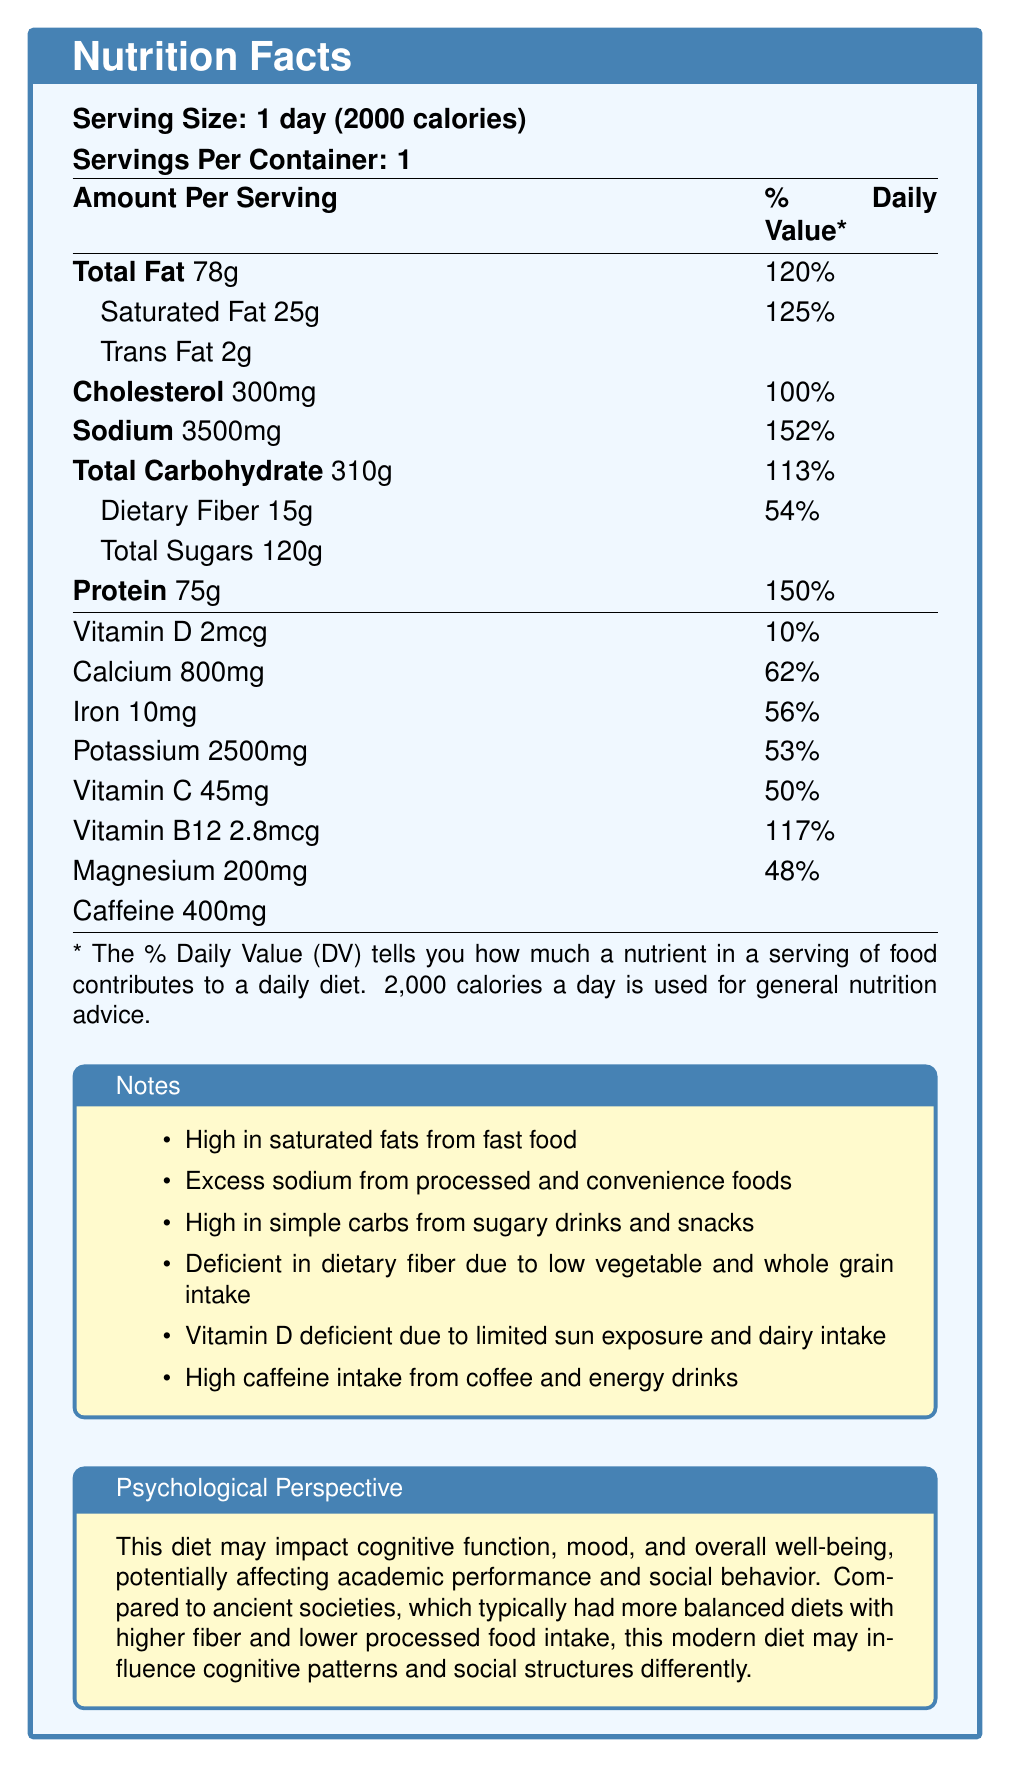what is the serving size? The serving size is clearly stated at the beginning of the document as "1 day (2000 calories)".
Answer: 1 day (2000 calories) How much Total Fat is consumed per day? According to the nutrition facts table, the amount of Total Fat per day is 78 grams.
Answer: 78g What percentage of the Daily Value is the sodium content? The sodium content is listed as 3500mg, which is 152% of the Daily Value.
Answer: 152% How does caffeine intake compare to recommended levels? The document notes that high caffeine intake comes from coffee and energy drinks.
Answer: High How much Vitamin D is consumed per day? The table lists 2mcg of Vitamin D per day, which is 10% of the Daily Value.
Answer: 2mcg What nutrient is consumed at 150% of the Daily Value? A. Vitamin D B. Protein C. Iron The nutrition facts table shows that Protein is consumed at 150% of the Daily Value.
Answer: B. Protein Which nutrient is primarily deficient due to low vegetable and whole grain intake? 1. Vitamin D 2. Dietary Fiber 3. Calcium 4. Magnesium The notes indicate that dietary fiber deficiency is due to low vegetable and whole grain intake.
Answer: 2. Dietary Fiber Is the daily intake of cholesterol within the recommended levels? The cholesterol level is 300mg, which is exactly 100% of the Daily Value.
Answer: Yes Summarize the main nutritional concerns outlined in this document. The primary concerns are the excessive amounts of unhealthy fats, sodium, sugars, and caffeine, coupled with deficiencies in essential micronutrients.
Answer: The document highlights a typical college student's diet that is high in saturated fats, sodium, simple carbohydrates, and caffeine while being deficient in dietary fiber, Vitamin D, calcium, iron, potassium, Vitamin C, and magnesium. How does the college student's diet potentially impact cognitive function and mood? The psychological perspective box mentions that these nutritional imbalances could impact cognitive function and mood.
Answer: The high intake of unhealthy components and deficiency in essential nutrients can negatively impact cognitive function, mood, and overall well-being, affecting academic performance and social behavior. Which historical societies typically had more balanced diets? The additional notes mention that ancient societies typically had more balanced diets with higher fiber and lower processed food intake.
Answer: Ancient societies What is the dietary fiber consumption per day as a percentage of the daily value? According to the nutrition table, dietary fiber is consumed at 15g per day, which is 54% of the Daily Value.
Answer: 54% Can we determine the individual's physical activity level based on the document? The document provides dietary information but does not mention anything about physical activity levels.
Answer: Not enough information Is Vitamin C intake sufficient according to the Daily Value? The Vitamin C intake is 45mg per day, which is only 50% of the Daily Value, indicating it is not sufficient.
Answer: No What is the note regarding the source of trans fat? The note next to trans fat states that it comes from fried foods and baked goods.
Answer: From fried foods and baked goods In what way can excessive caffeine intake affect college students? The notes highlight high caffeine intake from coffee and energy drinks, which is often used as a study aid or to combat fatigue yet could negatively affect cognitive function and mood.
Answer: It may serve as a study aid or to combat fatigue, but can also affect cognitive function and mood. 